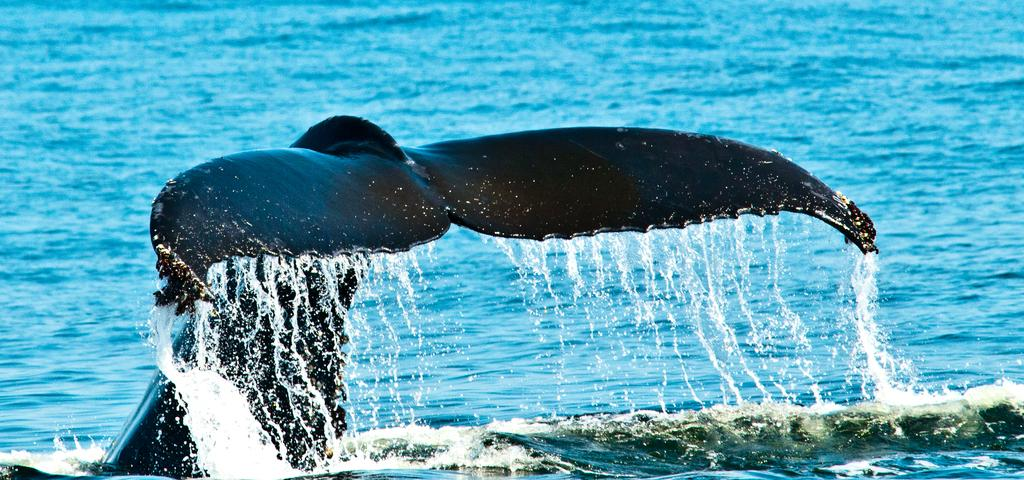What animal is the main subject of the image? There is a whale in the image. Where is the whale located? The whale is in the water. What is the purpose of the gun in the image? There is no gun present in the image; it only features a whale in the water. 